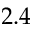Convert formula to latex. <formula><loc_0><loc_0><loc_500><loc_500>2 . 4</formula> 